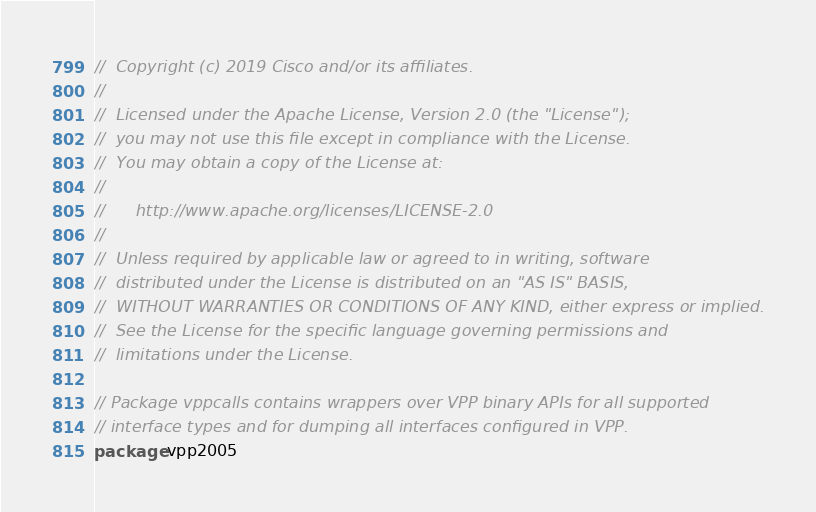Convert code to text. <code><loc_0><loc_0><loc_500><loc_500><_Go_>//  Copyright (c) 2019 Cisco and/or its affiliates.
//
//  Licensed under the Apache License, Version 2.0 (the "License");
//  you may not use this file except in compliance with the License.
//  You may obtain a copy of the License at:
//
//      http://www.apache.org/licenses/LICENSE-2.0
//
//  Unless required by applicable law or agreed to in writing, software
//  distributed under the License is distributed on an "AS IS" BASIS,
//  WITHOUT WARRANTIES OR CONDITIONS OF ANY KIND, either express or implied.
//  See the License for the specific language governing permissions and
//  limitations under the License.

// Package vppcalls contains wrappers over VPP binary APIs for all supported
// interface types and for dumping all interfaces configured in VPP.
package vpp2005
</code> 